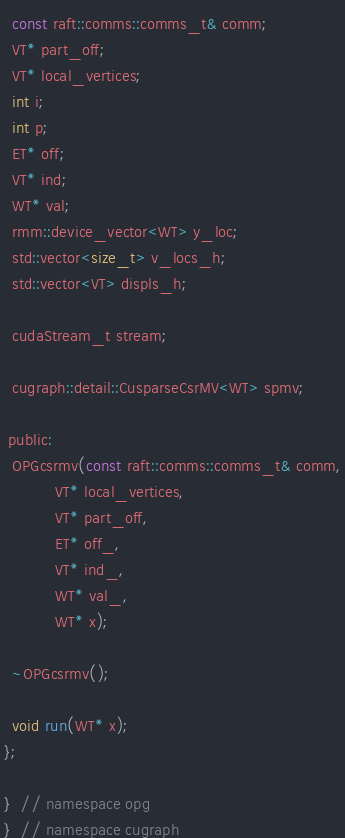<code> <loc_0><loc_0><loc_500><loc_500><_Cuda_>  const raft::comms::comms_t& comm;
  VT* part_off;
  VT* local_vertices;
  int i;
  int p;
  ET* off;
  VT* ind;
  WT* val;
  rmm::device_vector<WT> y_loc;
  std::vector<size_t> v_locs_h;
  std::vector<VT> displs_h;

  cudaStream_t stream;

  cugraph::detail::CusparseCsrMV<WT> spmv;

 public:
  OPGcsrmv(const raft::comms::comms_t& comm,
           VT* local_vertices,
           VT* part_off,
           ET* off_,
           VT* ind_,
           WT* val_,
           WT* x);

  ~OPGcsrmv();

  void run(WT* x);
};

}  // namespace opg
}  // namespace cugraph
</code> 